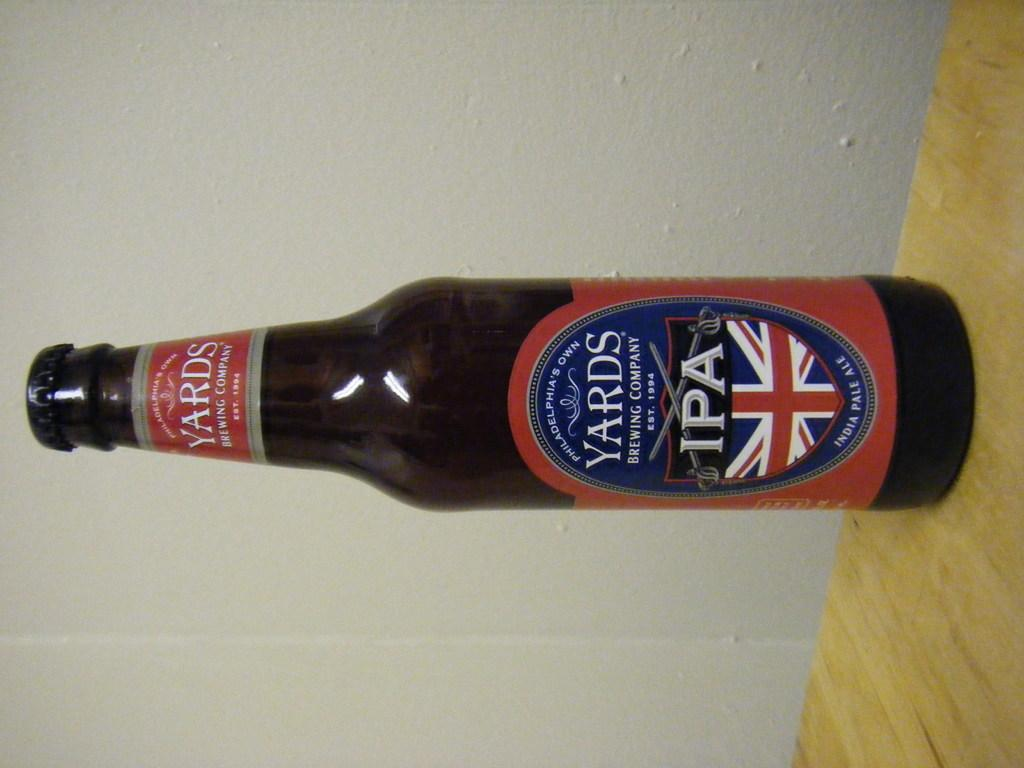<image>
Relay a brief, clear account of the picture shown. A single bottle of YARDS IPA sits on a wooden surface. 